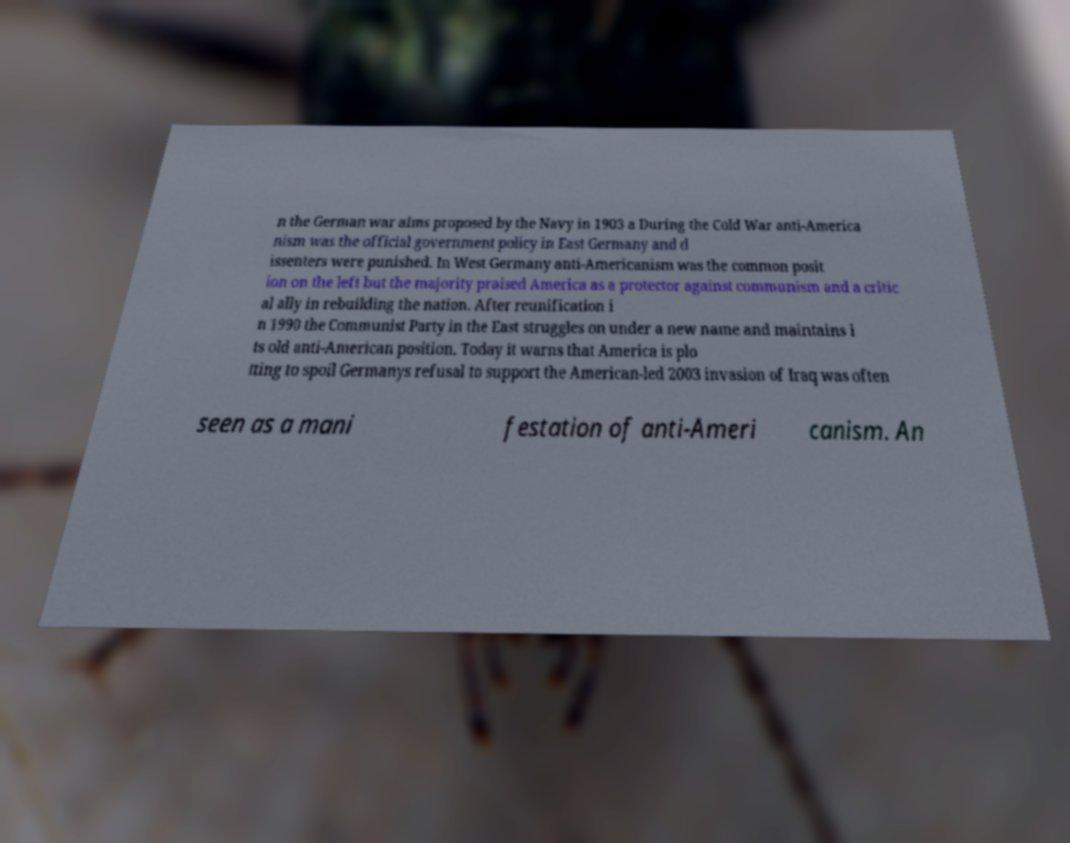What messages or text are displayed in this image? I need them in a readable, typed format. n the German war aims proposed by the Navy in 1903 a During the Cold War anti-America nism was the official government policy in East Germany and d issenters were punished. In West Germany anti-Americanism was the common posit ion on the left but the majority praised America as a protector against communism and a critic al ally in rebuilding the nation. After reunification i n 1990 the Communist Party in the East struggles on under a new name and maintains i ts old anti-American position. Today it warns that America is plo tting to spoil Germanys refusal to support the American-led 2003 invasion of Iraq was often seen as a mani festation of anti-Ameri canism. An 